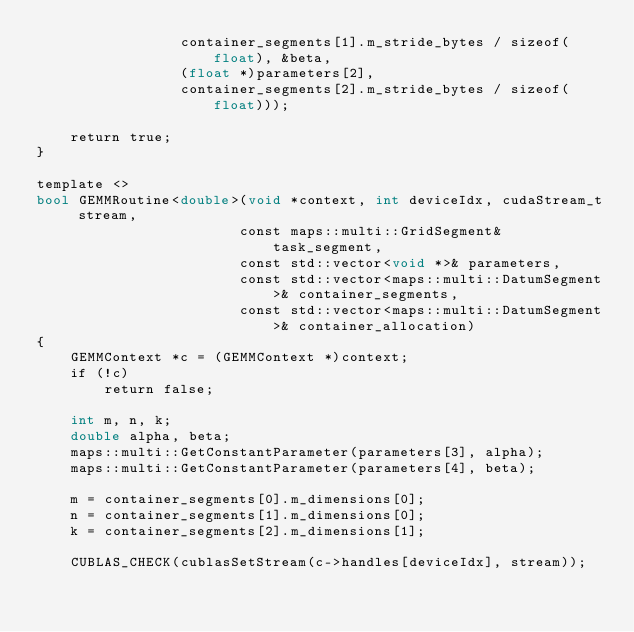<code> <loc_0><loc_0><loc_500><loc_500><_Cuda_>                 container_segments[1].m_stride_bytes / sizeof(float), &beta, 
                 (float *)parameters[2],
                 container_segments[2].m_stride_bytes / sizeof(float)));

    return true;
}

template <>
bool GEMMRoutine<double>(void *context, int deviceIdx, cudaStream_t stream,
                        const maps::multi::GridSegment& task_segment,
                        const std::vector<void *>& parameters,
                        const std::vector<maps::multi::DatumSegment>& container_segments,
                        const std::vector<maps::multi::DatumSegment>& container_allocation)
{
    GEMMContext *c = (GEMMContext *)context;
    if (!c)
        return false;

    int m, n, k;
    double alpha, beta;
    maps::multi::GetConstantParameter(parameters[3], alpha);
    maps::multi::GetConstantParameter(parameters[4], beta);
    
    m = container_segments[0].m_dimensions[0];
    n = container_segments[1].m_dimensions[0];
    k = container_segments[2].m_dimensions[1];

    CUBLAS_CHECK(cublasSetStream(c->handles[deviceIdx], stream));</code> 